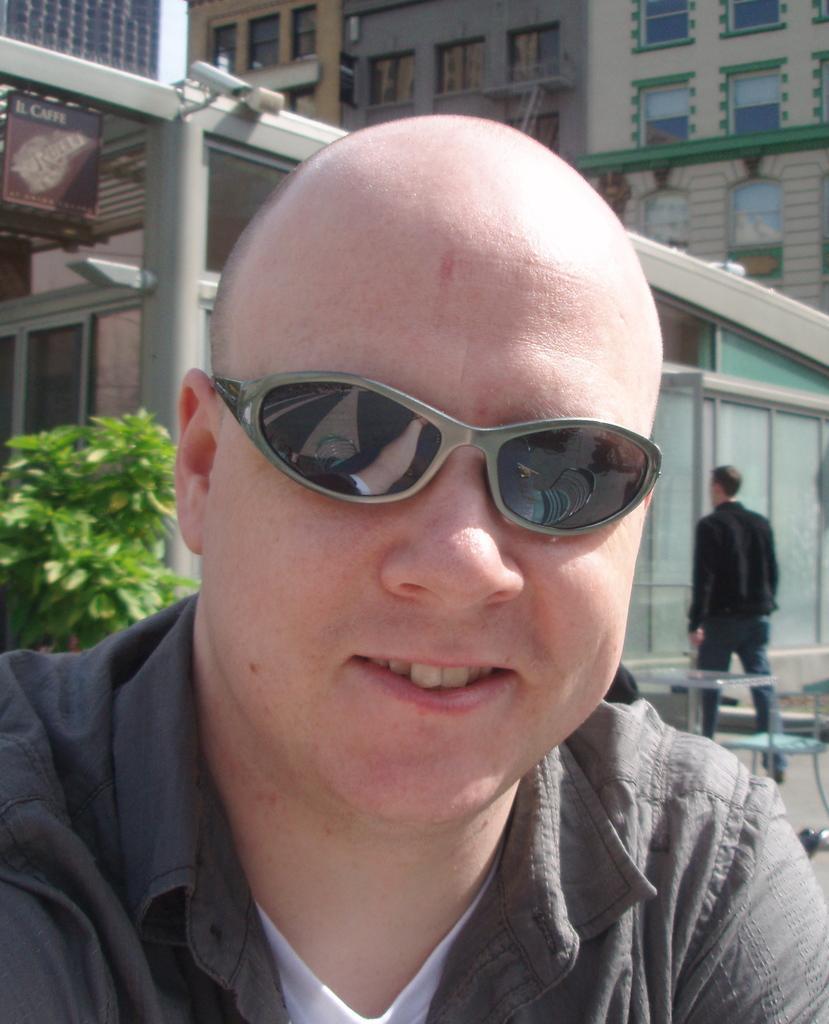How would you summarize this image in a sentence or two? In this picture, we can see a few people, chairs, tables, glass doors, camera, buildings with windows and we can see the posters. 